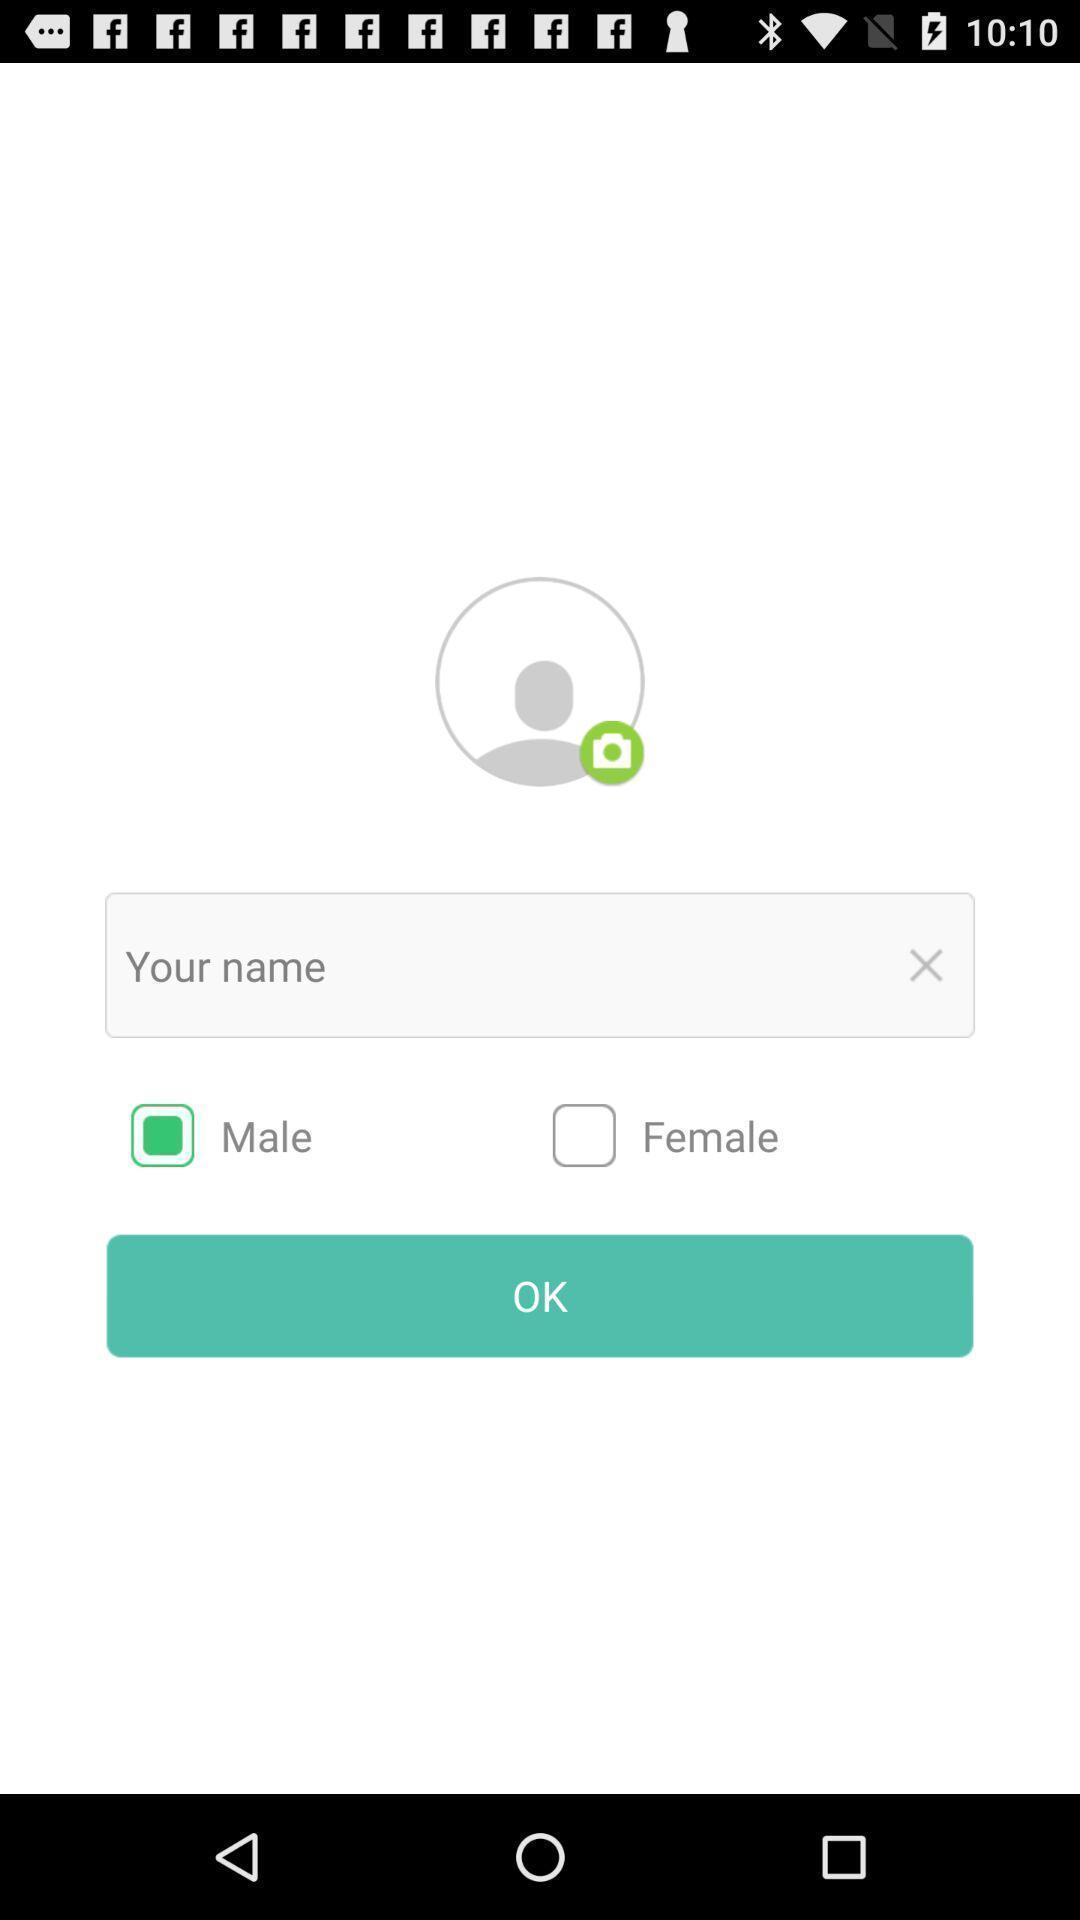Provide a description of this screenshot. Page to add profile details. 